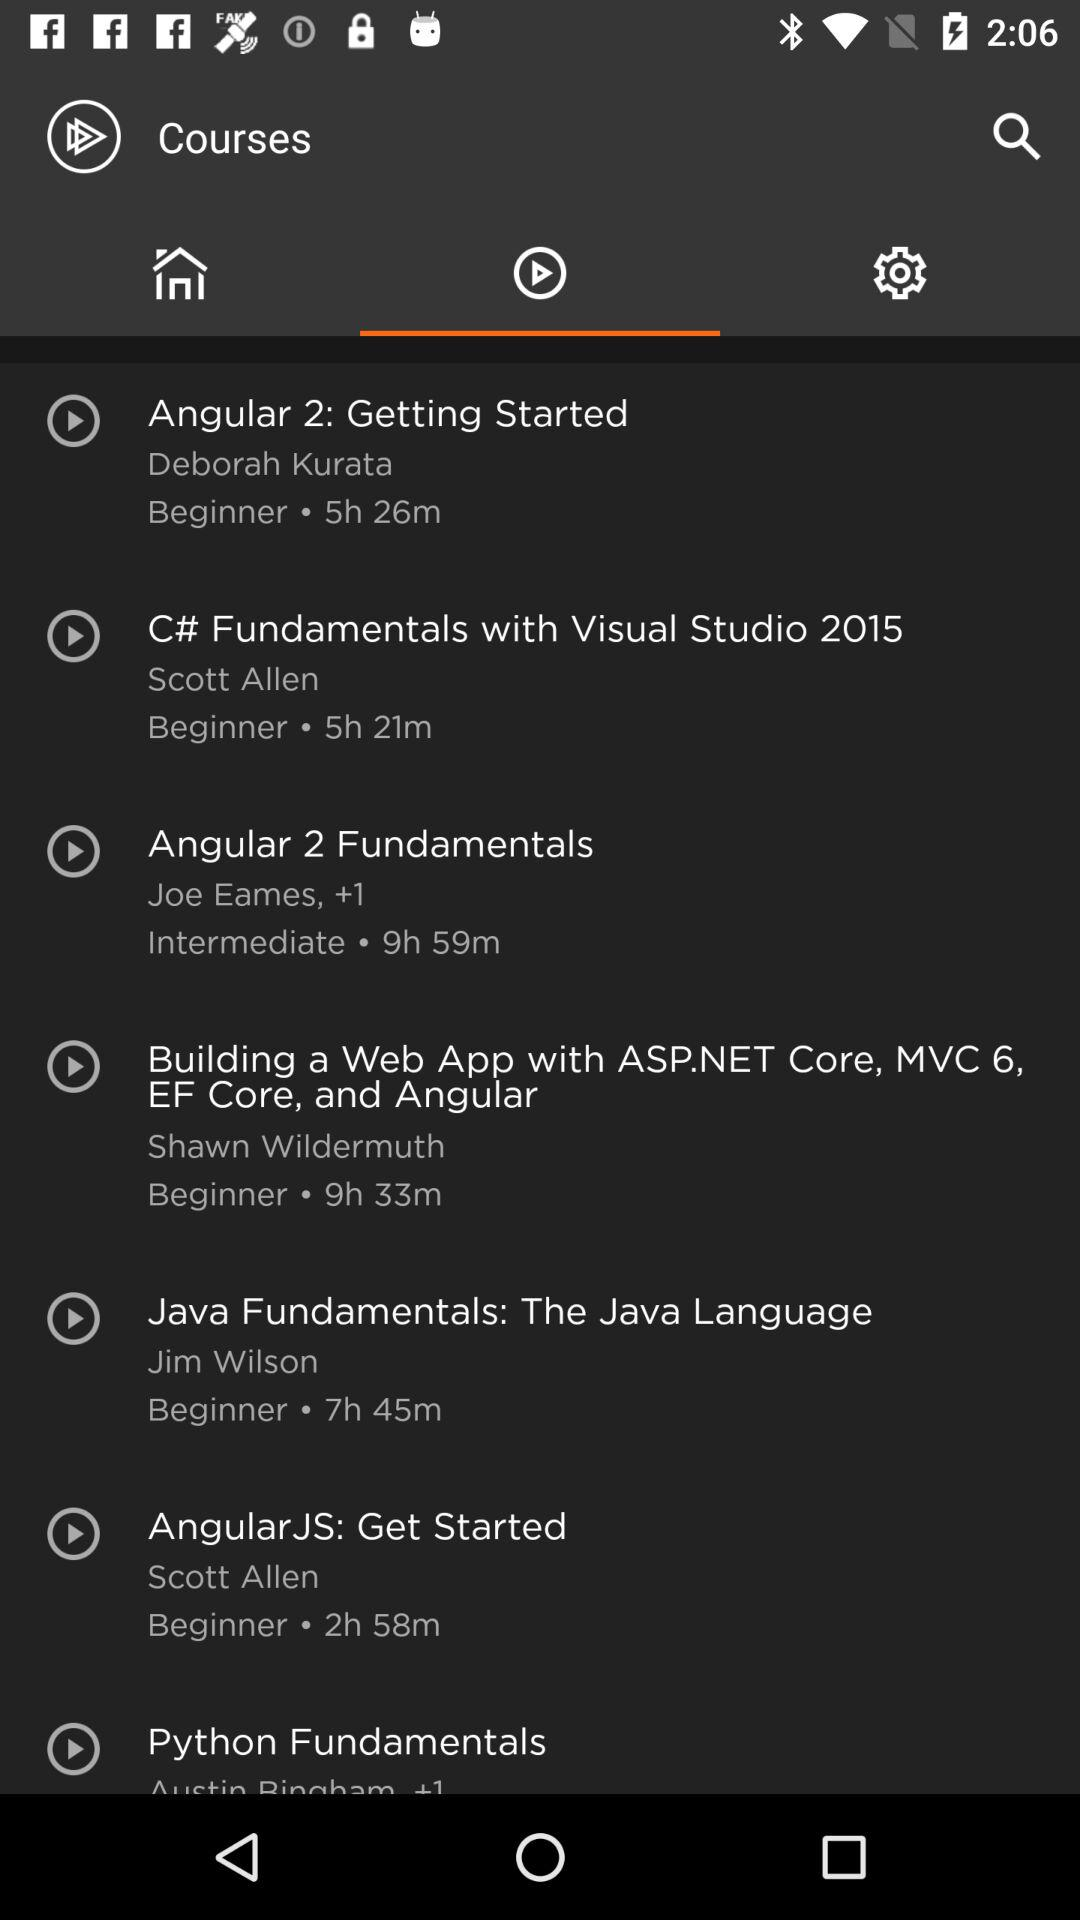What course has a duration of 2 hours 58 minutes? The course is "Angular JS: Get Started". 